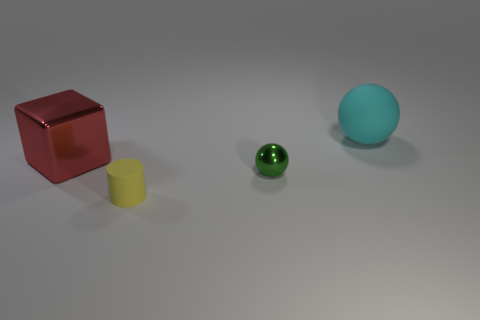What objects are present in the image and what are their colors? The image depicts four objects: a red cube on the left, a yellow cylinder in the middle, a small green sphere, and a larger blue sphere on the right. 